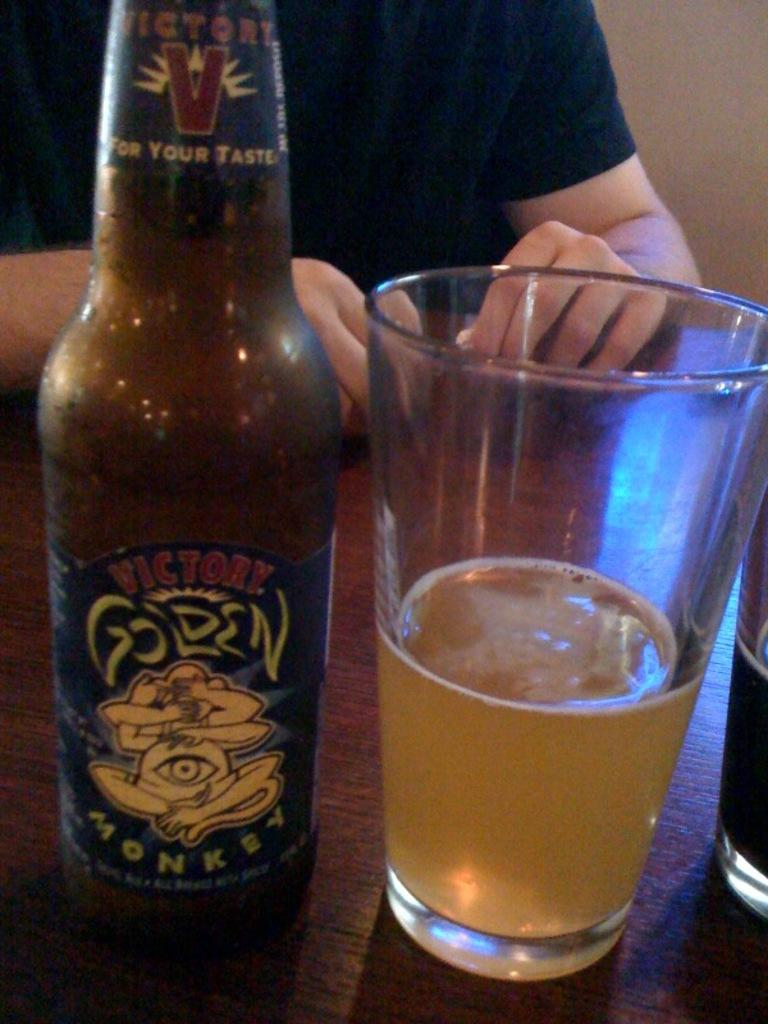Provide a one-sentence caption for the provided image. a person with a beer bottle that says Golden next to them. 